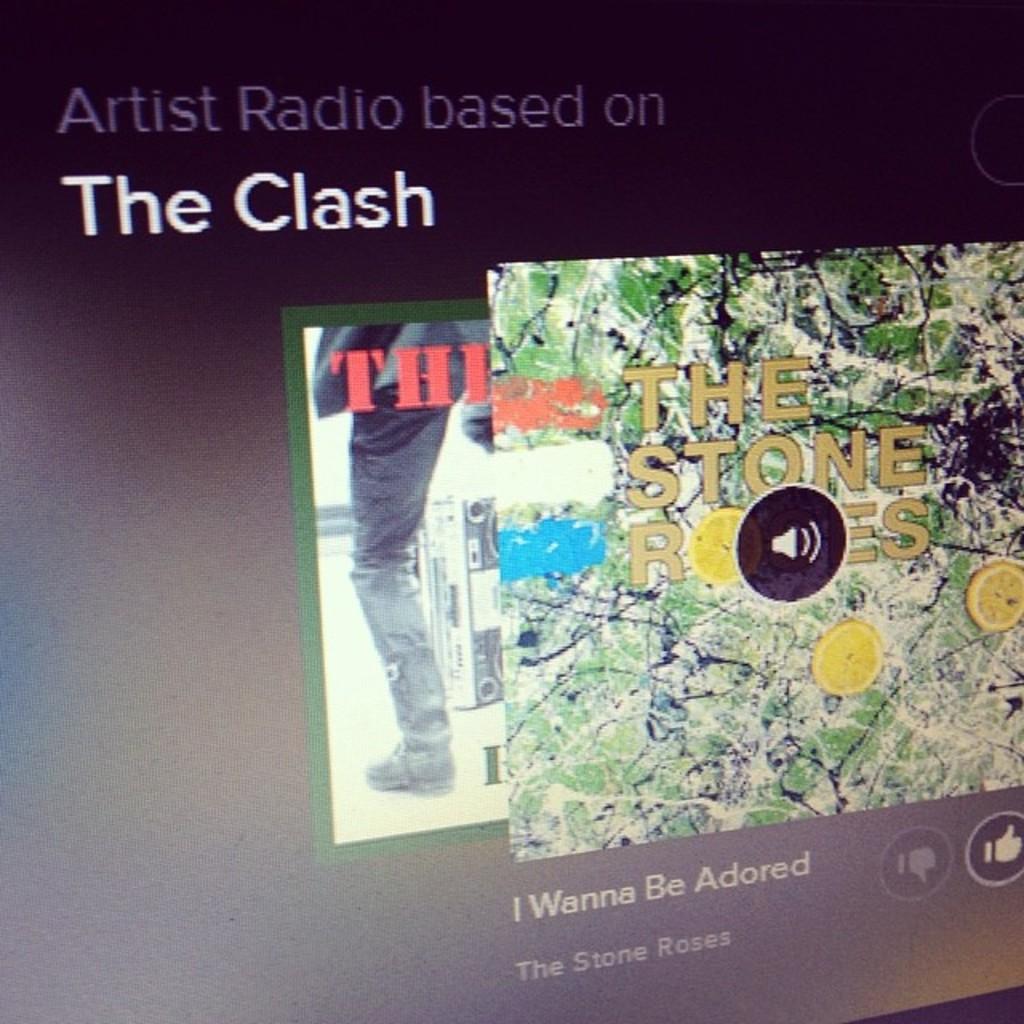What band is this based on?
Make the answer very short. The clash. 